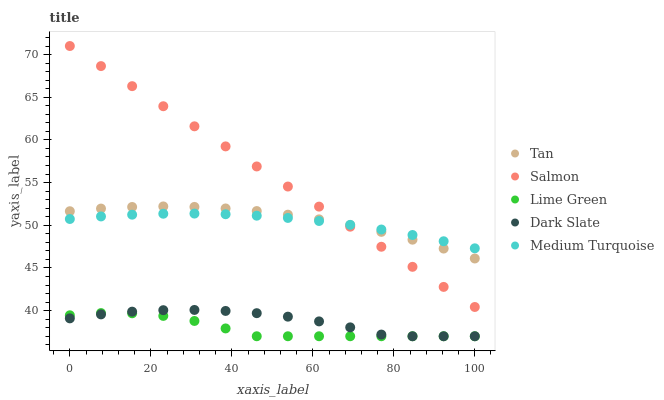Does Lime Green have the minimum area under the curve?
Answer yes or no. Yes. Does Salmon have the maximum area under the curve?
Answer yes or no. Yes. Does Tan have the minimum area under the curve?
Answer yes or no. No. Does Tan have the maximum area under the curve?
Answer yes or no. No. Is Salmon the smoothest?
Answer yes or no. Yes. Is Dark Slate the roughest?
Answer yes or no. Yes. Is Tan the smoothest?
Answer yes or no. No. Is Tan the roughest?
Answer yes or no. No. Does Lime Green have the lowest value?
Answer yes or no. Yes. Does Tan have the lowest value?
Answer yes or no. No. Does Salmon have the highest value?
Answer yes or no. Yes. Does Tan have the highest value?
Answer yes or no. No. Is Lime Green less than Medium Turquoise?
Answer yes or no. Yes. Is Tan greater than Lime Green?
Answer yes or no. Yes. Does Salmon intersect Medium Turquoise?
Answer yes or no. Yes. Is Salmon less than Medium Turquoise?
Answer yes or no. No. Is Salmon greater than Medium Turquoise?
Answer yes or no. No. Does Lime Green intersect Medium Turquoise?
Answer yes or no. No. 